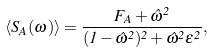<formula> <loc_0><loc_0><loc_500><loc_500>\langle S _ { A } ( \omega ) \rangle = \frac { F _ { A } + \hat { \omega } ^ { 2 } } { ( 1 - \hat { \omega } ^ { 2 } ) ^ { 2 } + \hat { \omega } ^ { 2 } \epsilon ^ { 2 } } ,</formula> 